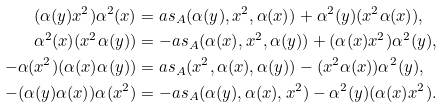<formula> <loc_0><loc_0><loc_500><loc_500>( \alpha ( y ) x ^ { 2 } ) \alpha ^ { 2 } ( x ) & = a s _ { A } ( \alpha ( y ) , x ^ { 2 } , \alpha ( x ) ) + \alpha ^ { 2 } ( y ) ( x ^ { 2 } \alpha ( x ) ) , \\ \alpha ^ { 2 } ( x ) ( x ^ { 2 } \alpha ( y ) ) & = - a s _ { A } ( \alpha ( x ) , x ^ { 2 } , \alpha ( y ) ) + ( \alpha ( x ) x ^ { 2 } ) \alpha ^ { 2 } ( y ) , \\ - \alpha ( x ^ { 2 } ) ( \alpha ( x ) \alpha ( y ) ) & = a s _ { A } ( x ^ { 2 } , \alpha ( x ) , \alpha ( y ) ) - ( x ^ { 2 } \alpha ( x ) ) \alpha ^ { 2 } ( y ) , \\ - ( \alpha ( y ) \alpha ( x ) ) \alpha ( x ^ { 2 } ) & = - a s _ { A } ( \alpha ( y ) , \alpha ( x ) , x ^ { 2 } ) - \alpha ^ { 2 } ( y ) ( \alpha ( x ) x ^ { 2 } ) .</formula> 